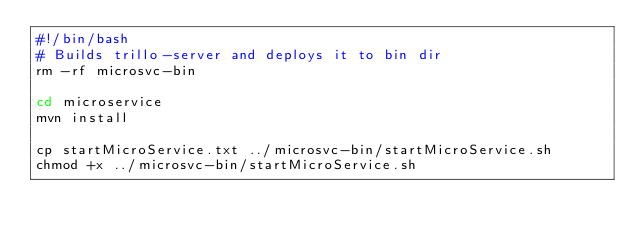<code> <loc_0><loc_0><loc_500><loc_500><_Bash_>#!/bin/bash
# Builds trillo-server and deploys it to bin dir
rm -rf microsvc-bin

cd microservice
mvn install

cp startMicroService.txt ../microsvc-bin/startMicroService.sh
chmod +x ../microsvc-bin/startMicroService.sh
</code> 